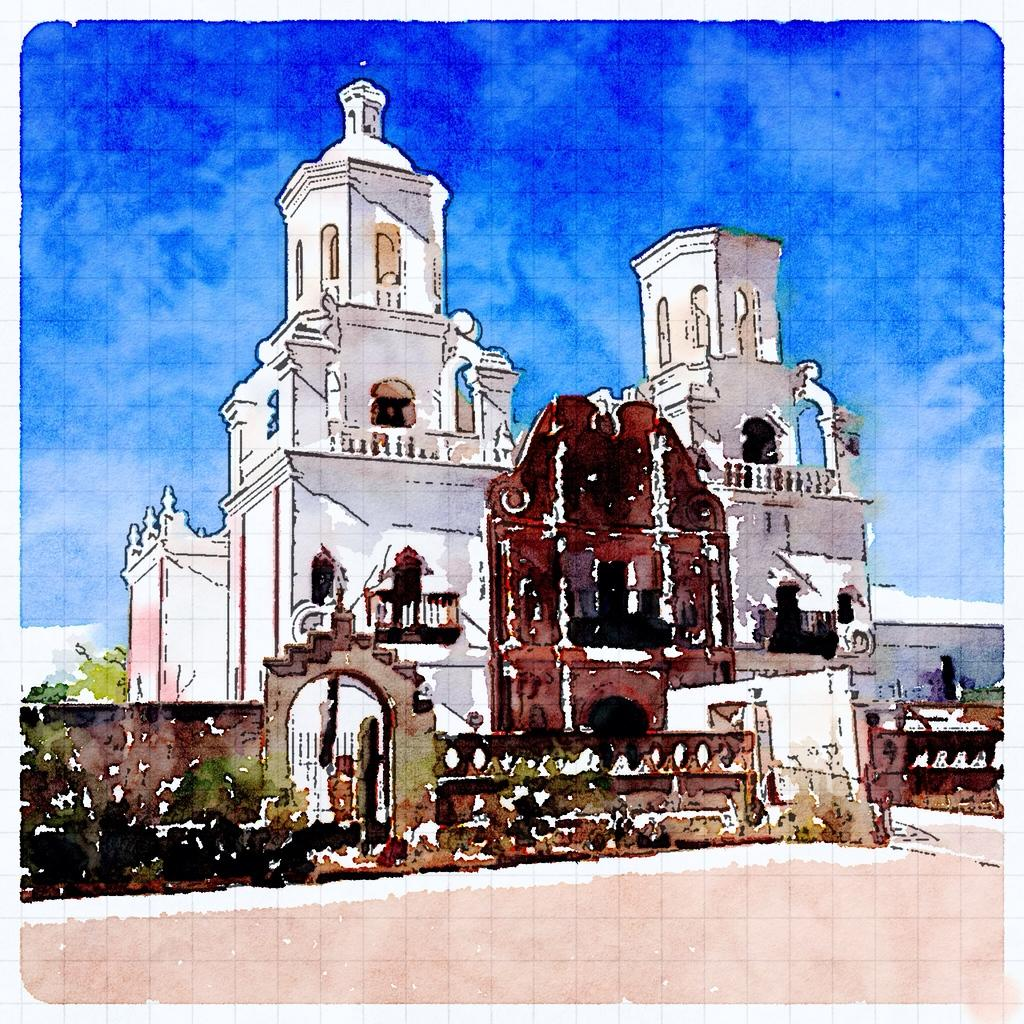What type of structure is in the image? There is a building in the image. What can be seen in the background of the image? The sky is visible in the background of the image. What is the condition of the sky in the image? Clouds are present in the sky. What type of hair can be seen on the building in the image? There is no hair present on the building in the image. 